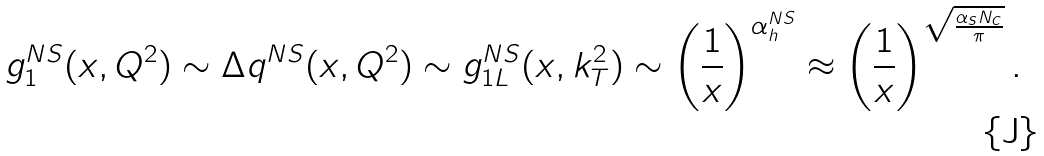<formula> <loc_0><loc_0><loc_500><loc_500>g _ { 1 } ^ { N S } ( x , Q ^ { 2 } ) \sim \Delta q ^ { N S } ( x , Q ^ { 2 } ) \sim g _ { 1 L } ^ { N S } ( x , k _ { T } ^ { 2 } ) \sim \left ( \frac { 1 } { x } \right ) ^ { \alpha _ { h } ^ { N S } } \approx \left ( \frac { 1 } { x } \right ) ^ { { \sqrt { \frac { \alpha _ { s } N _ { c } } { \pi } } } } .</formula> 